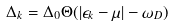<formula> <loc_0><loc_0><loc_500><loc_500>\Delta _ { k } = \Delta _ { 0 } \Theta ( | \epsilon _ { k } - \mu | - \omega _ { D } )</formula> 